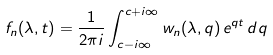<formula> <loc_0><loc_0><loc_500><loc_500>f _ { n } ( \lambda , t ) = \frac { 1 } { 2 \pi i } \int _ { c - i \infty } ^ { c + i \infty } w _ { n } ( \lambda , q ) \, e ^ { q t } \, d q</formula> 